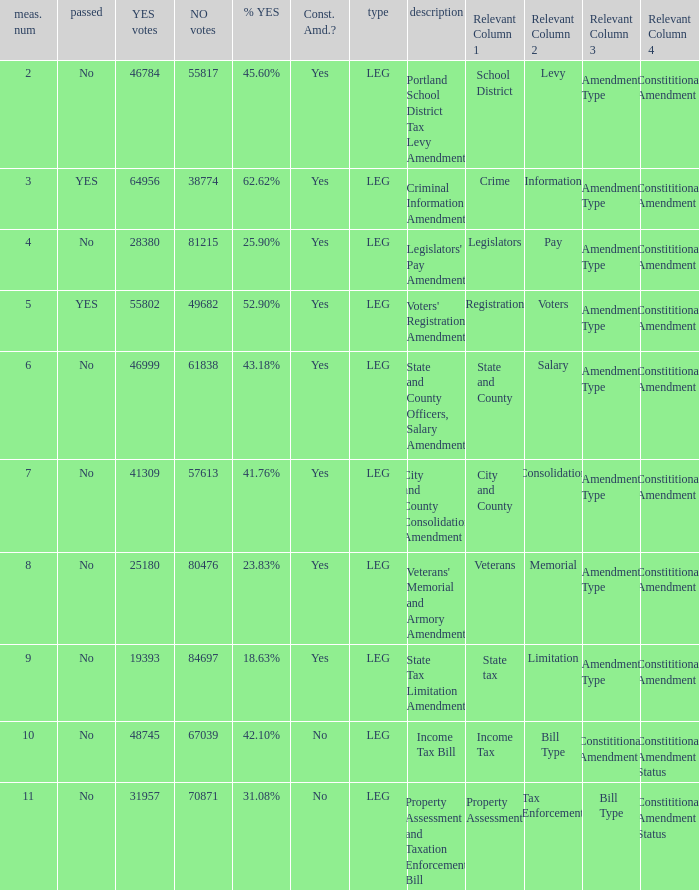Who had 41.76% yes votes City and County Consolidation Amendment. 